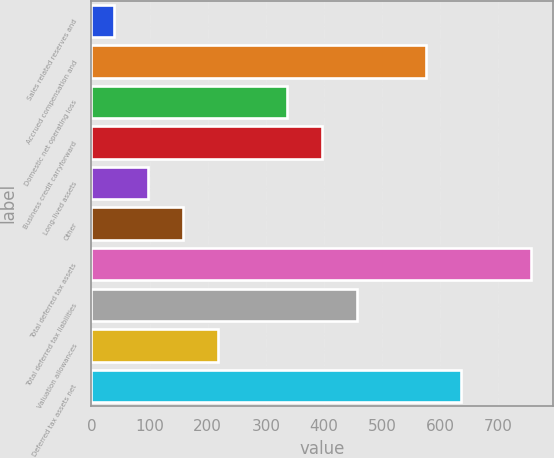Convert chart to OTSL. <chart><loc_0><loc_0><loc_500><loc_500><bar_chart><fcel>Sales related reserves and<fcel>Accrued compensation and<fcel>Domestic net operating loss<fcel>Business credit carryforward<fcel>Long-lived assets<fcel>Other<fcel>Total deferred tax assets<fcel>Total deferred tax liabilities<fcel>Valuation allowances<fcel>Deferred tax assets net<nl><fcel>38<fcel>576.2<fcel>337<fcel>396.8<fcel>97.8<fcel>157.6<fcel>755.6<fcel>456.6<fcel>217.4<fcel>636<nl></chart> 